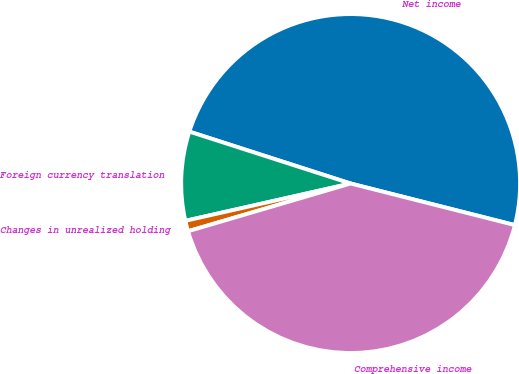Convert chart. <chart><loc_0><loc_0><loc_500><loc_500><pie_chart><fcel>Net income<fcel>Foreign currency translation<fcel>Changes in unrealized holding<fcel>Comprehensive income<nl><fcel>48.99%<fcel>8.49%<fcel>1.01%<fcel>41.51%<nl></chart> 